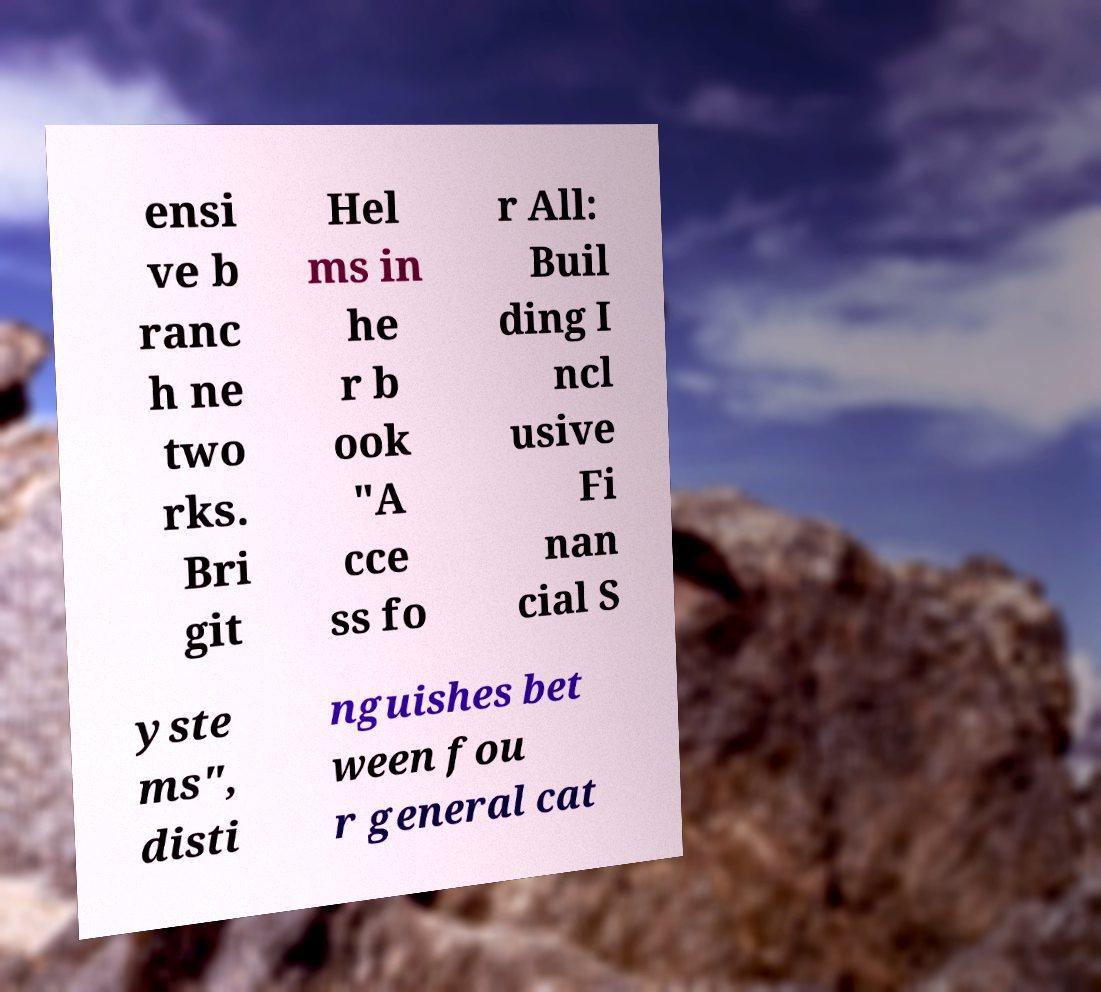Could you assist in decoding the text presented in this image and type it out clearly? ensi ve b ranc h ne two rks. Bri git Hel ms in he r b ook "A cce ss fo r All: Buil ding I ncl usive Fi nan cial S yste ms", disti nguishes bet ween fou r general cat 